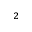Convert formula to latex. <formula><loc_0><loc_0><loc_500><loc_500>^ { 2 }</formula> 